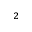Convert formula to latex. <formula><loc_0><loc_0><loc_500><loc_500>^ { 2 }</formula> 